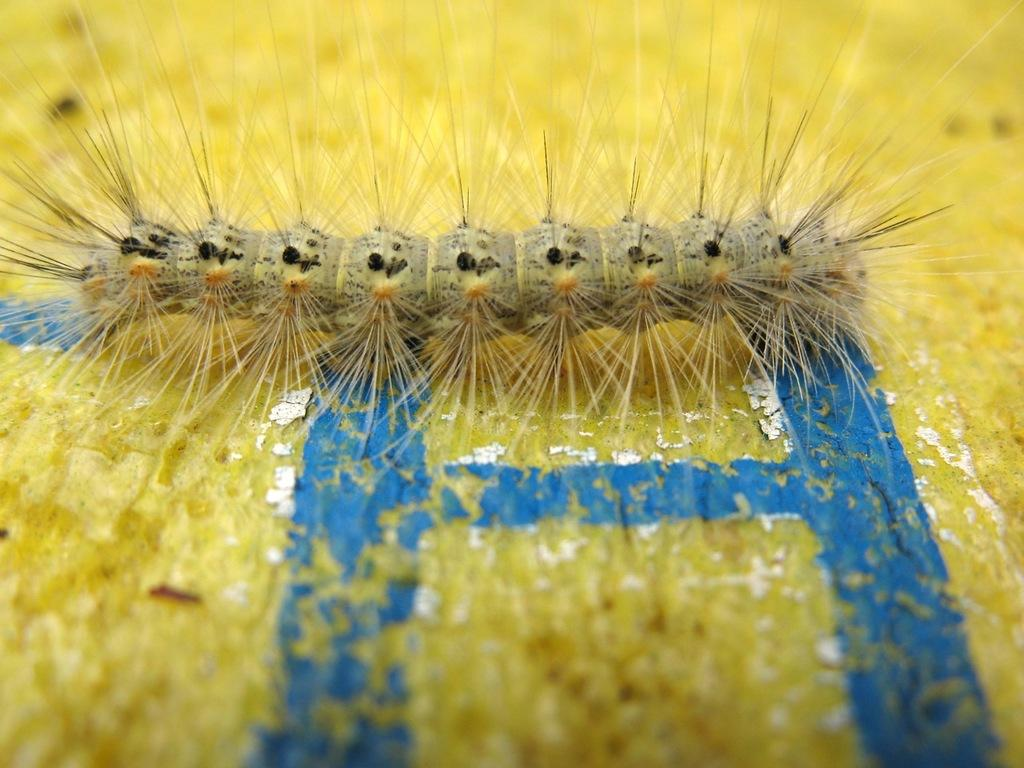What is the main subject of the picture? The main subject of the picture is an insect. Can you describe the surface the insect is on? The insect is on a yellow and blue color surface. What is the weight of the produce in the image? There is no produce present in the image, so it's not possible to determine its weight. 